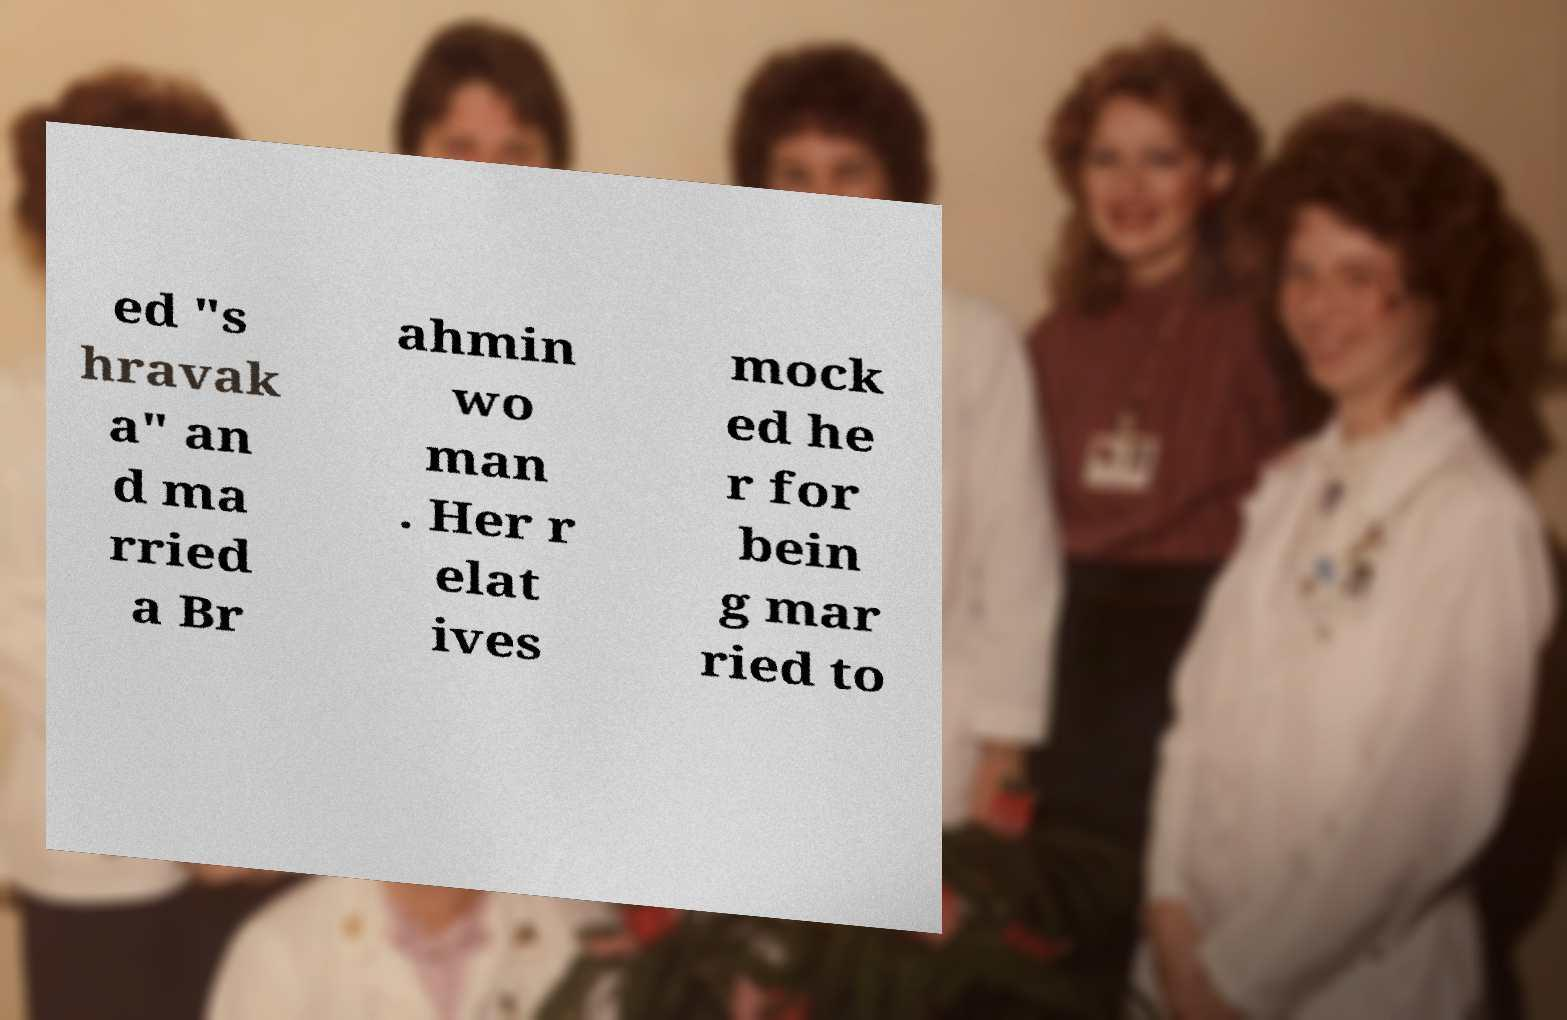What messages or text are displayed in this image? I need them in a readable, typed format. ed "s hravak a" an d ma rried a Br ahmin wo man . Her r elat ives mock ed he r for bein g mar ried to 